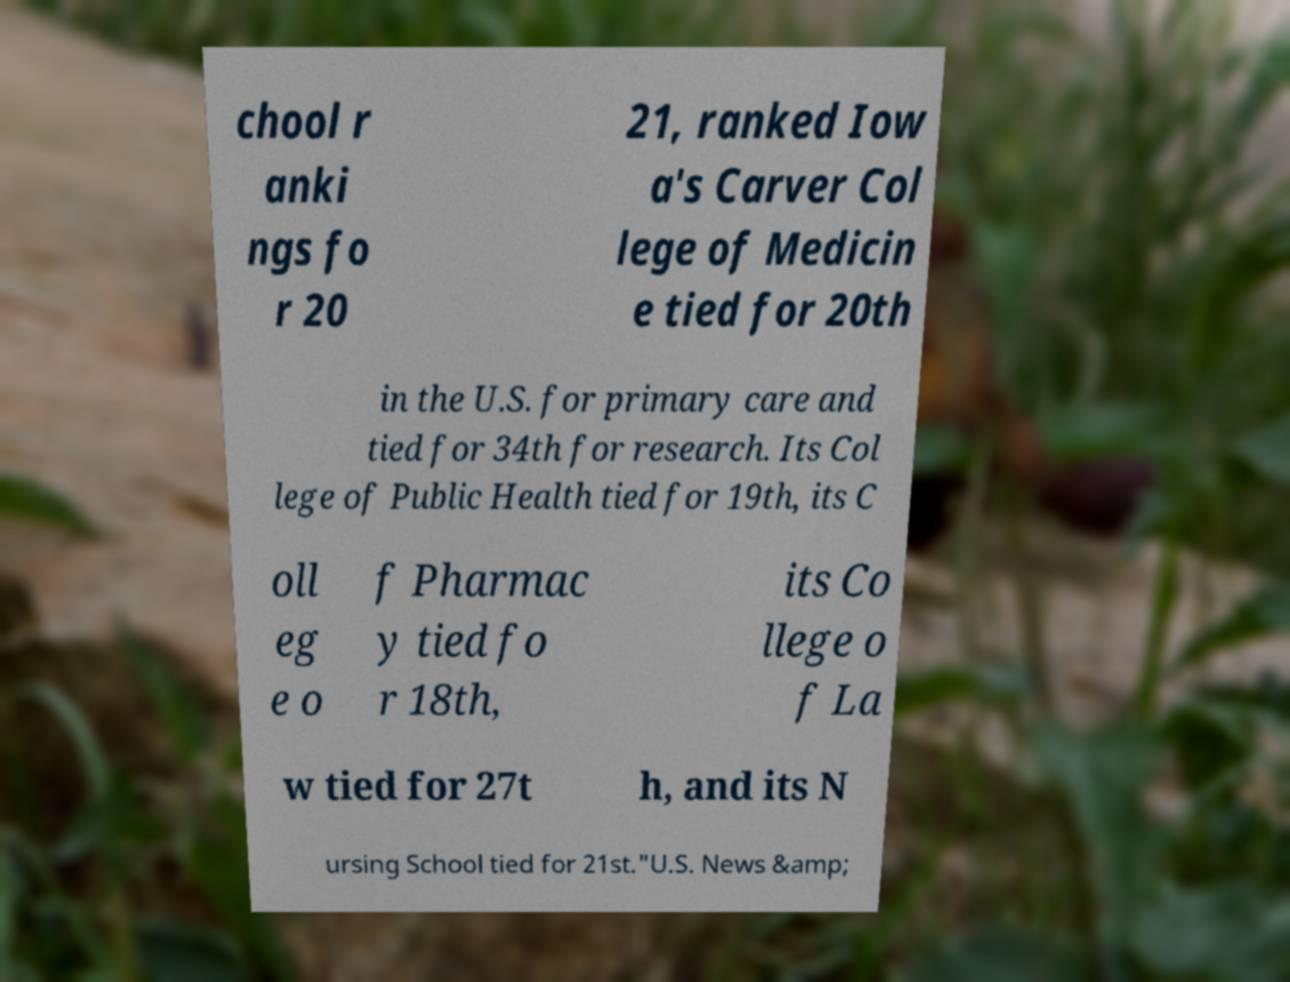Could you assist in decoding the text presented in this image and type it out clearly? chool r anki ngs fo r 20 21, ranked Iow a's Carver Col lege of Medicin e tied for 20th in the U.S. for primary care and tied for 34th for research. Its Col lege of Public Health tied for 19th, its C oll eg e o f Pharmac y tied fo r 18th, its Co llege o f La w tied for 27t h, and its N ursing School tied for 21st."U.S. News &amp; 